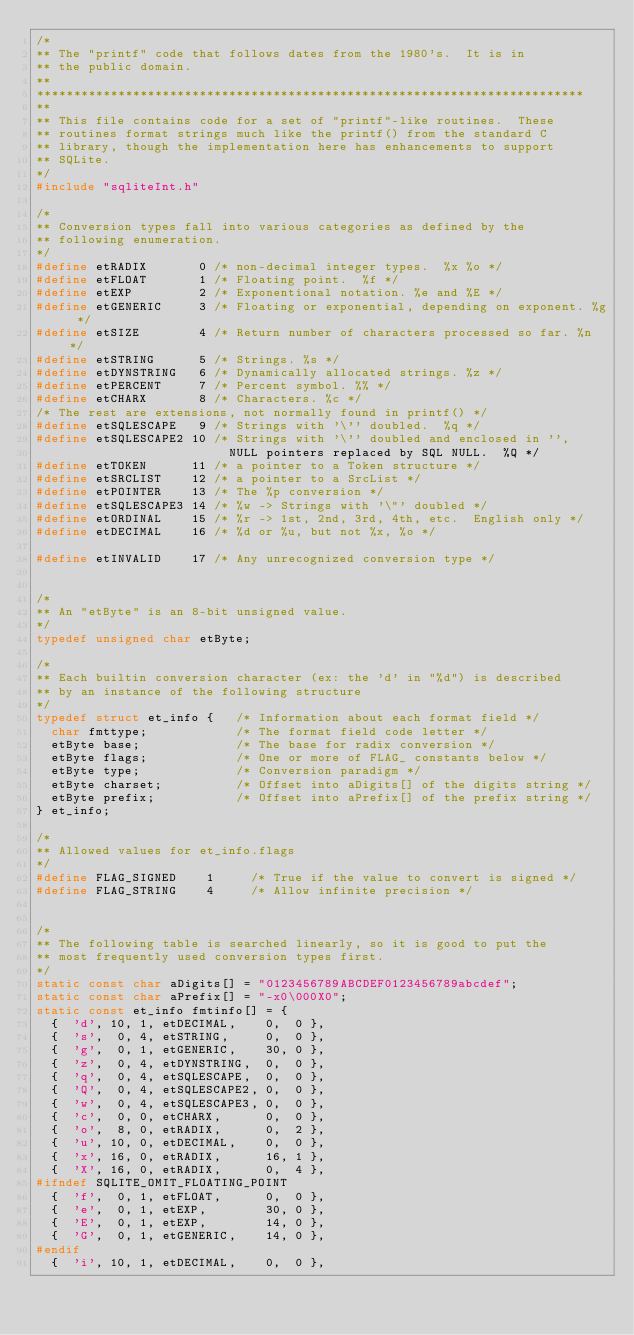Convert code to text. <code><loc_0><loc_0><loc_500><loc_500><_C_>/*
** The "printf" code that follows dates from the 1980's.  It is in
** the public domain. 
**
**************************************************************************
**
** This file contains code for a set of "printf"-like routines.  These
** routines format strings much like the printf() from the standard C
** library, though the implementation here has enhancements to support
** SQLite.
*/
#include "sqliteInt.h"

/*
** Conversion types fall into various categories as defined by the
** following enumeration.
*/
#define etRADIX       0 /* non-decimal integer types.  %x %o */
#define etFLOAT       1 /* Floating point.  %f */
#define etEXP         2 /* Exponentional notation. %e and %E */
#define etGENERIC     3 /* Floating or exponential, depending on exponent. %g */
#define etSIZE        4 /* Return number of characters processed so far. %n */
#define etSTRING      5 /* Strings. %s */
#define etDYNSTRING   6 /* Dynamically allocated strings. %z */
#define etPERCENT     7 /* Percent symbol. %% */
#define etCHARX       8 /* Characters. %c */
/* The rest are extensions, not normally found in printf() */
#define etSQLESCAPE   9 /* Strings with '\'' doubled.  %q */
#define etSQLESCAPE2 10 /* Strings with '\'' doubled and enclosed in '',
                          NULL pointers replaced by SQL NULL.  %Q */
#define etTOKEN      11 /* a pointer to a Token structure */
#define etSRCLIST    12 /* a pointer to a SrcList */
#define etPOINTER    13 /* The %p conversion */
#define etSQLESCAPE3 14 /* %w -> Strings with '\"' doubled */
#define etORDINAL    15 /* %r -> 1st, 2nd, 3rd, 4th, etc.  English only */
#define etDECIMAL    16 /* %d or %u, but not %x, %o */

#define etINVALID    17 /* Any unrecognized conversion type */


/*
** An "etByte" is an 8-bit unsigned value.
*/
typedef unsigned char etByte;

/*
** Each builtin conversion character (ex: the 'd' in "%d") is described
** by an instance of the following structure
*/
typedef struct et_info {   /* Information about each format field */
  char fmttype;            /* The format field code letter */
  etByte base;             /* The base for radix conversion */
  etByte flags;            /* One or more of FLAG_ constants below */
  etByte type;             /* Conversion paradigm */
  etByte charset;          /* Offset into aDigits[] of the digits string */
  etByte prefix;           /* Offset into aPrefix[] of the prefix string */
} et_info;

/*
** Allowed values for et_info.flags
*/
#define FLAG_SIGNED    1     /* True if the value to convert is signed */
#define FLAG_STRING    4     /* Allow infinite precision */


/*
** The following table is searched linearly, so it is good to put the
** most frequently used conversion types first.
*/
static const char aDigits[] = "0123456789ABCDEF0123456789abcdef";
static const char aPrefix[] = "-x0\000X0";
static const et_info fmtinfo[] = {
  {  'd', 10, 1, etDECIMAL,    0,  0 },
  {  's',  0, 4, etSTRING,     0,  0 },
  {  'g',  0, 1, etGENERIC,    30, 0 },
  {  'z',  0, 4, etDYNSTRING,  0,  0 },
  {  'q',  0, 4, etSQLESCAPE,  0,  0 },
  {  'Q',  0, 4, etSQLESCAPE2, 0,  0 },
  {  'w',  0, 4, etSQLESCAPE3, 0,  0 },
  {  'c',  0, 0, etCHARX,      0,  0 },
  {  'o',  8, 0, etRADIX,      0,  2 },
  {  'u', 10, 0, etDECIMAL,    0,  0 },
  {  'x', 16, 0, etRADIX,      16, 1 },
  {  'X', 16, 0, etRADIX,      0,  4 },
#ifndef SQLITE_OMIT_FLOATING_POINT
  {  'f',  0, 1, etFLOAT,      0,  0 },
  {  'e',  0, 1, etEXP,        30, 0 },
  {  'E',  0, 1, etEXP,        14, 0 },
  {  'G',  0, 1, etGENERIC,    14, 0 },
#endif
  {  'i', 10, 1, etDECIMAL,    0,  0 },</code> 